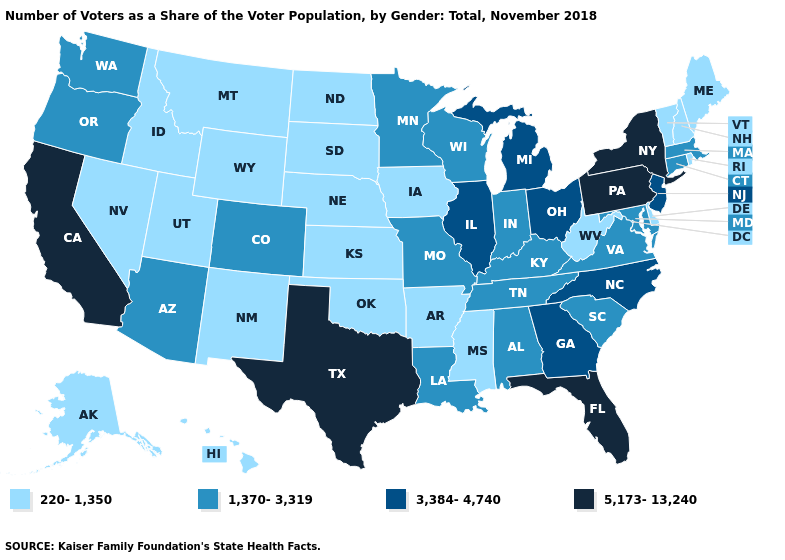What is the value of Wyoming?
Give a very brief answer. 220-1,350. Which states hav the highest value in the South?
Be succinct. Florida, Texas. Is the legend a continuous bar?
Quick response, please. No. Which states have the lowest value in the USA?
Be succinct. Alaska, Arkansas, Delaware, Hawaii, Idaho, Iowa, Kansas, Maine, Mississippi, Montana, Nebraska, Nevada, New Hampshire, New Mexico, North Dakota, Oklahoma, Rhode Island, South Dakota, Utah, Vermont, West Virginia, Wyoming. Does Connecticut have a lower value than Ohio?
Write a very short answer. Yes. What is the value of South Dakota?
Keep it brief. 220-1,350. Does Massachusetts have a lower value than Connecticut?
Short answer required. No. Is the legend a continuous bar?
Short answer required. No. What is the lowest value in the USA?
Concise answer only. 220-1,350. Does Alaska have the highest value in the West?
Be succinct. No. Which states have the lowest value in the MidWest?
Short answer required. Iowa, Kansas, Nebraska, North Dakota, South Dakota. Name the states that have a value in the range 5,173-13,240?
Answer briefly. California, Florida, New York, Pennsylvania, Texas. What is the value of Hawaii?
Quick response, please. 220-1,350. Name the states that have a value in the range 220-1,350?
Short answer required. Alaska, Arkansas, Delaware, Hawaii, Idaho, Iowa, Kansas, Maine, Mississippi, Montana, Nebraska, Nevada, New Hampshire, New Mexico, North Dakota, Oklahoma, Rhode Island, South Dakota, Utah, Vermont, West Virginia, Wyoming. Does Ohio have a lower value than Wisconsin?
Give a very brief answer. No. 